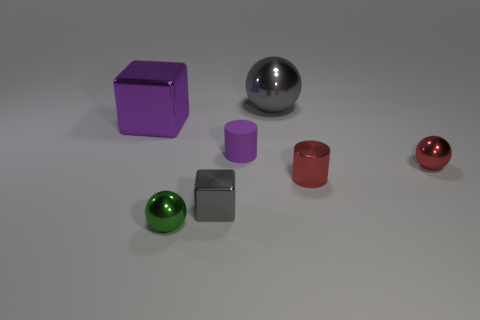Which objects in the image look like they could be the heaviest, and why? Judging by size and material appearance, the larger objects may seem heavier. For instance, the large gray metallic sphere and the large purple cube appear as if they could be the heaviest items due to their substantial relative size and solid-looking materials, which suggest weight. 